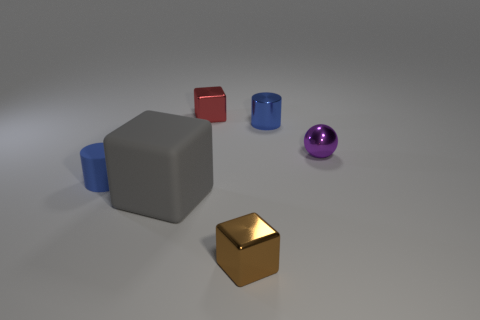Subtract all blue cylinders. How many were subtracted if there are1blue cylinders left? 1 Add 4 big gray matte things. How many objects exist? 10 Subtract all cylinders. How many objects are left? 4 Subtract 0 gray balls. How many objects are left? 6 Subtract all small blue rubber cylinders. Subtract all gray matte things. How many objects are left? 4 Add 2 blue cylinders. How many blue cylinders are left? 4 Add 5 tiny cylinders. How many tiny cylinders exist? 7 